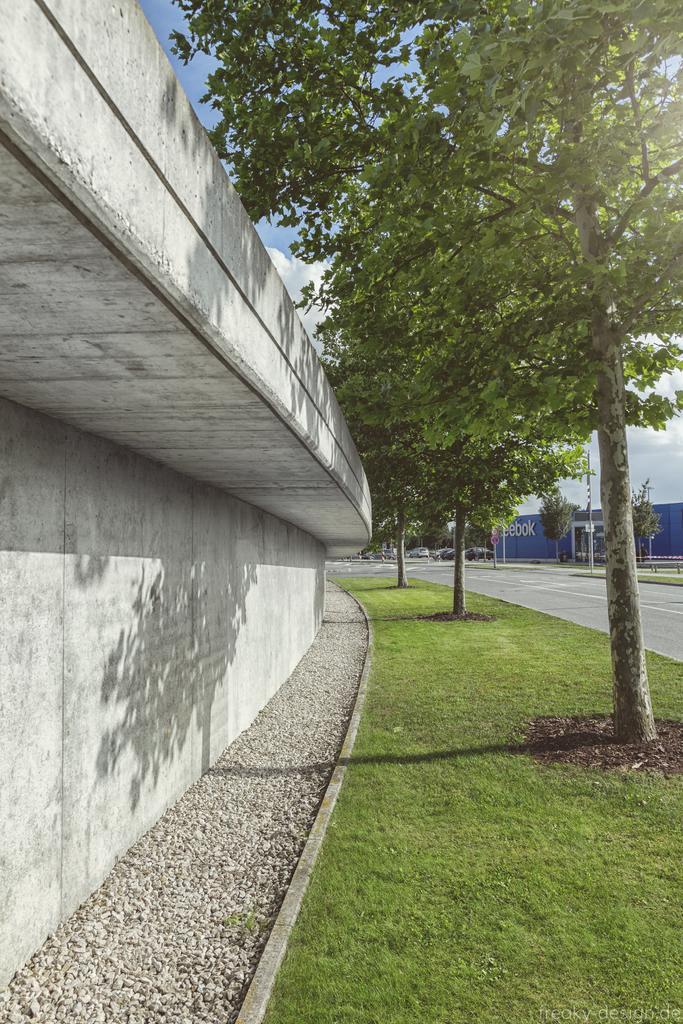How would you summarize this image in a sentence or two? In this image, we can see a wall, grass, few trees, road, vehicles, pole. Background there is a sky. 